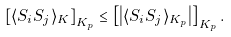<formula> <loc_0><loc_0><loc_500><loc_500>\left [ \langle S _ { i } S _ { j } \rangle _ { K } \right ] _ { K _ { p } } \leq \left [ \left | \langle S _ { i } S _ { j } \rangle _ { K _ { p } } \right | \right ] _ { K _ { p } } .</formula> 